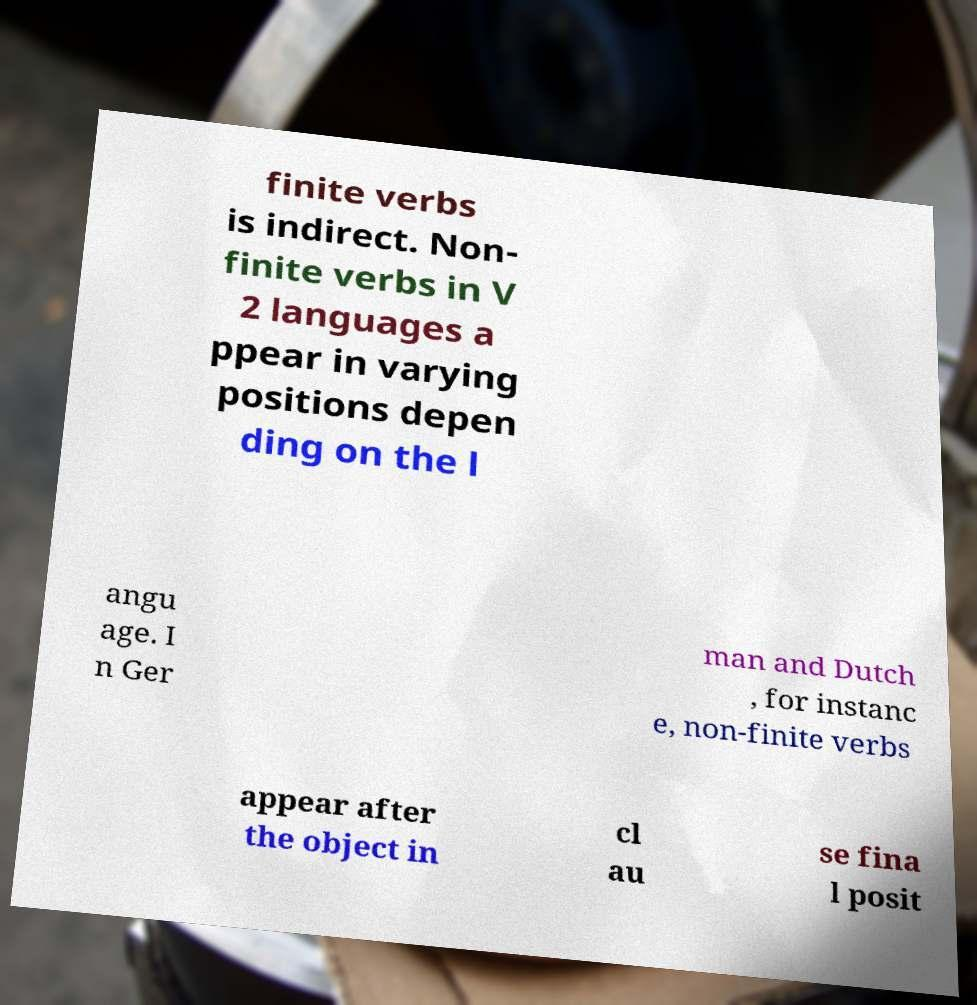Please read and relay the text visible in this image. What does it say? finite verbs is indirect. Non- finite verbs in V 2 languages a ppear in varying positions depen ding on the l angu age. I n Ger man and Dutch , for instanc e, non-finite verbs appear after the object in cl au se fina l posit 